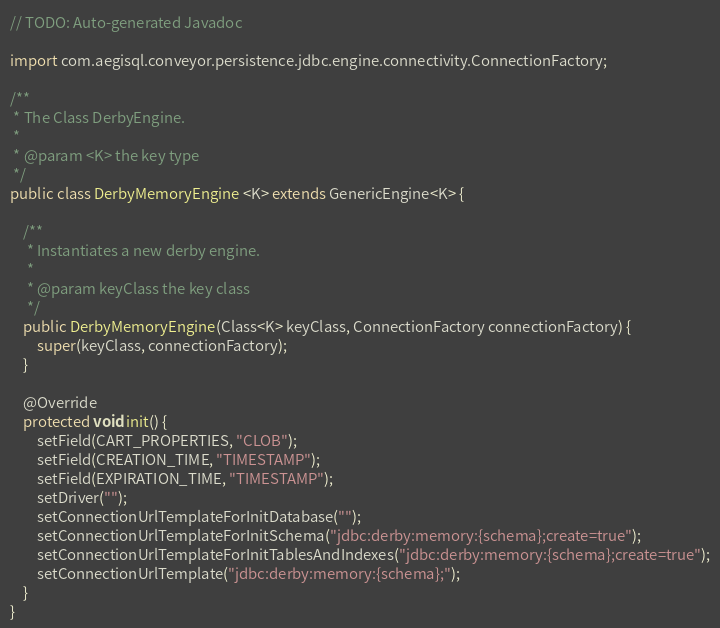<code> <loc_0><loc_0><loc_500><loc_500><_Java_>// TODO: Auto-generated Javadoc

import com.aegisql.conveyor.persistence.jdbc.engine.connectivity.ConnectionFactory;

/**
 * The Class DerbyEngine.
 *
 * @param <K> the key type
 */
public class DerbyMemoryEngine <K> extends GenericEngine<K> {
	
	/**
	 * Instantiates a new derby engine.
	 *
	 * @param keyClass the key class
	 */
	public DerbyMemoryEngine(Class<K> keyClass, ConnectionFactory connectionFactory) {
		super(keyClass, connectionFactory);
	}

	@Override
	protected void init() {
		setField(CART_PROPERTIES, "CLOB");
		setField(CREATION_TIME, "TIMESTAMP");
		setField(EXPIRATION_TIME, "TIMESTAMP");
		setDriver("");
		setConnectionUrlTemplateForInitDatabase("");
		setConnectionUrlTemplateForInitSchema("jdbc:derby:memory:{schema};create=true");
		setConnectionUrlTemplateForInitTablesAndIndexes("jdbc:derby:memory:{schema};create=true");
		setConnectionUrlTemplate("jdbc:derby:memory:{schema};");
	}
}
</code> 